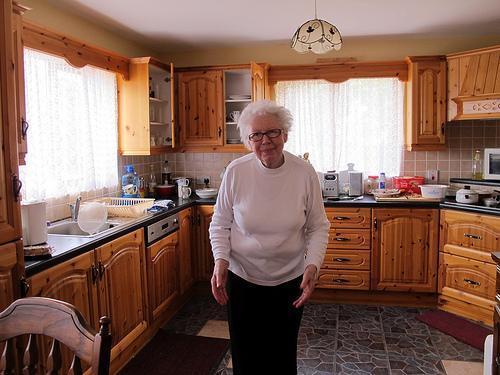How many people are there?
Give a very brief answer. 1. 